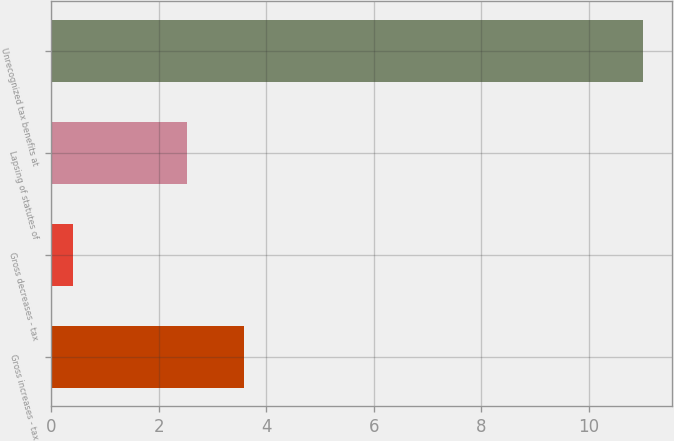Convert chart to OTSL. <chart><loc_0><loc_0><loc_500><loc_500><bar_chart><fcel>Gross increases - tax<fcel>Gross decreases - tax<fcel>Lapsing of statutes of<fcel>Unrecognized tax benefits at<nl><fcel>3.58<fcel>0.4<fcel>2.52<fcel>11<nl></chart> 